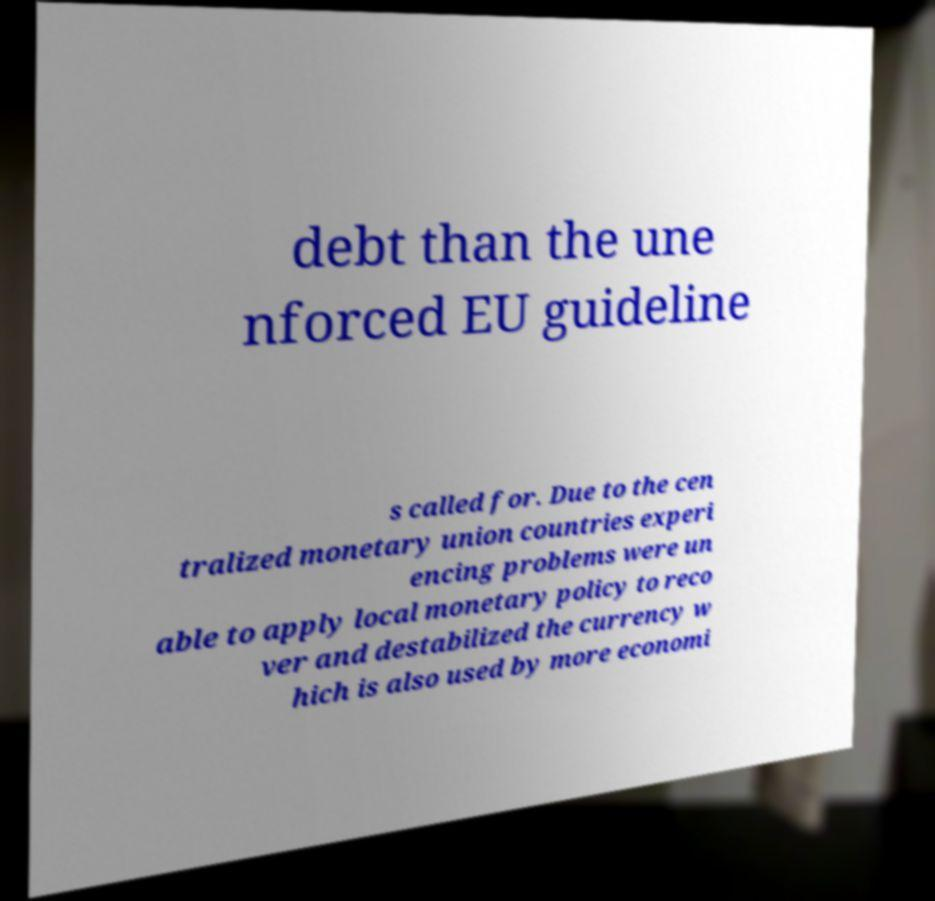Could you assist in decoding the text presented in this image and type it out clearly? debt than the une nforced EU guideline s called for. Due to the cen tralized monetary union countries experi encing problems were un able to apply local monetary policy to reco ver and destabilized the currency w hich is also used by more economi 